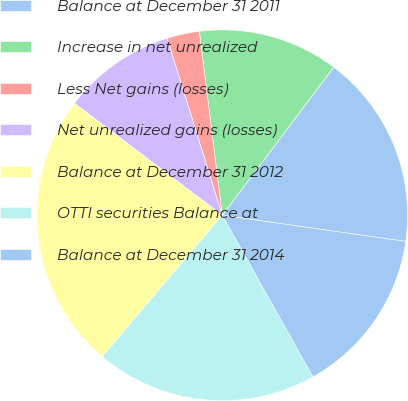Convert chart to OTSL. <chart><loc_0><loc_0><loc_500><loc_500><pie_chart><fcel>Balance at December 31 2011<fcel>Increase in net unrealized<fcel>Less Net gains (losses)<fcel>Net unrealized gains (losses)<fcel>Balance at December 31 2012<fcel>OTTI securities Balance at<fcel>Balance at December 31 2014<nl><fcel>16.98%<fcel>12.25%<fcel>2.83%<fcel>9.88%<fcel>24.12%<fcel>19.34%<fcel>14.61%<nl></chart> 